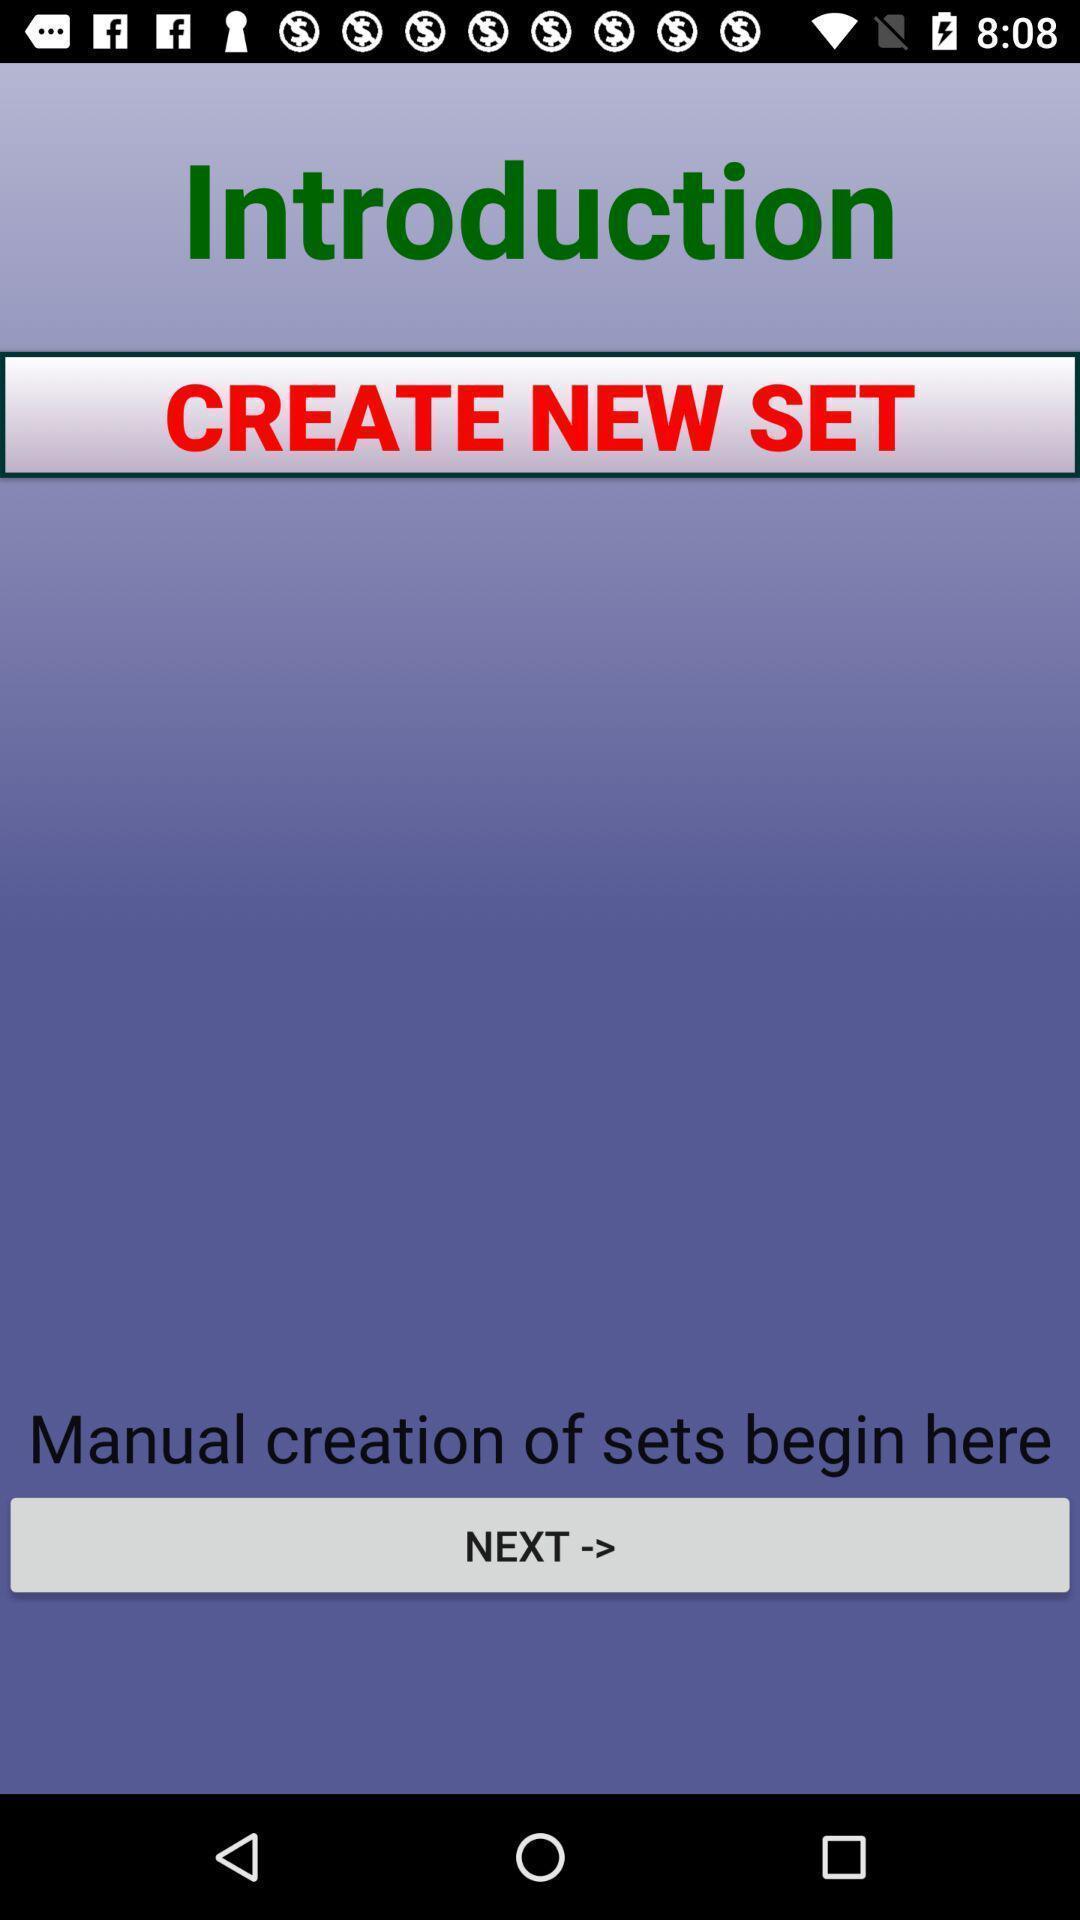Provide a textual representation of this image. Page with introduction for a study app. 